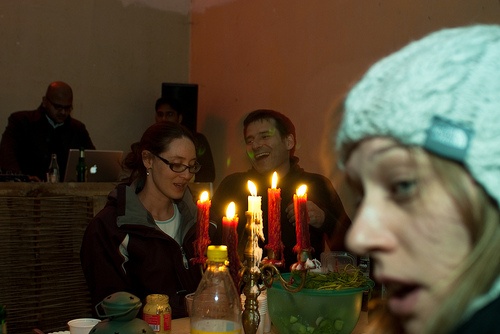<image>
Can you confirm if the man is to the left of the woman? Yes. From this viewpoint, the man is positioned to the left side relative to the woman. Is there a candle in front of the flame? No. The candle is not in front of the flame. The spatial positioning shows a different relationship between these objects. 